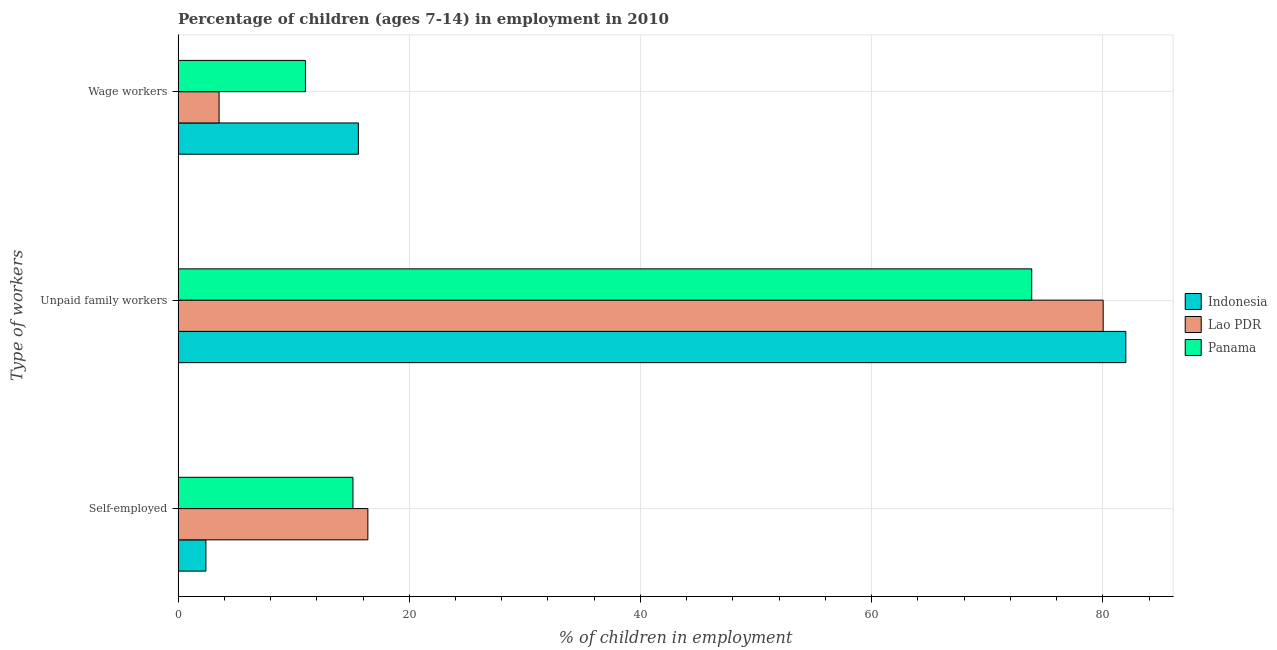What is the label of the 1st group of bars from the top?
Ensure brevity in your answer.  Wage workers. What is the percentage of children employed as wage workers in Panama?
Your answer should be very brief. 11.02. Across all countries, what is the maximum percentage of self employed children?
Offer a terse response. 16.42. Across all countries, what is the minimum percentage of children employed as wage workers?
Provide a short and direct response. 3.55. In which country was the percentage of children employed as wage workers maximum?
Keep it short and to the point. Indonesia. In which country was the percentage of self employed children minimum?
Give a very brief answer. Indonesia. What is the total percentage of self employed children in the graph?
Your answer should be very brief. 33.96. What is the difference between the percentage of children employed as wage workers in Indonesia and that in Lao PDR?
Your response must be concise. 12.05. What is the difference between the percentage of self employed children in Lao PDR and the percentage of children employed as unpaid family workers in Panama?
Keep it short and to the point. -57.43. What is the average percentage of children employed as wage workers per country?
Provide a short and direct response. 10.06. What is the difference between the percentage of self employed children and percentage of children employed as unpaid family workers in Indonesia?
Your response must be concise. -79.58. In how many countries, is the percentage of self employed children greater than 80 %?
Ensure brevity in your answer.  0. What is the ratio of the percentage of self employed children in Lao PDR to that in Panama?
Keep it short and to the point. 1.09. Is the percentage of children employed as wage workers in Panama less than that in Lao PDR?
Keep it short and to the point. No. What is the difference between the highest and the second highest percentage of children employed as unpaid family workers?
Keep it short and to the point. 1.96. What is the difference between the highest and the lowest percentage of children employed as unpaid family workers?
Your answer should be compact. 8.14. In how many countries, is the percentage of self employed children greater than the average percentage of self employed children taken over all countries?
Offer a terse response. 2. What does the 2nd bar from the bottom in Self-employed represents?
Your answer should be very brief. Lao PDR. Is it the case that in every country, the sum of the percentage of self employed children and percentage of children employed as unpaid family workers is greater than the percentage of children employed as wage workers?
Your answer should be very brief. Yes. How many bars are there?
Your answer should be compact. 9. Does the graph contain any zero values?
Provide a succinct answer. No. Does the graph contain grids?
Provide a short and direct response. Yes. Where does the legend appear in the graph?
Offer a very short reply. Center right. What is the title of the graph?
Offer a terse response. Percentage of children (ages 7-14) in employment in 2010. Does "St. Lucia" appear as one of the legend labels in the graph?
Offer a very short reply. No. What is the label or title of the X-axis?
Ensure brevity in your answer.  % of children in employment. What is the label or title of the Y-axis?
Offer a very short reply. Type of workers. What is the % of children in employment of Indonesia in Self-employed?
Your answer should be very brief. 2.41. What is the % of children in employment in Lao PDR in Self-employed?
Give a very brief answer. 16.42. What is the % of children in employment in Panama in Self-employed?
Provide a short and direct response. 15.13. What is the % of children in employment of Indonesia in Unpaid family workers?
Your answer should be compact. 81.99. What is the % of children in employment in Lao PDR in Unpaid family workers?
Give a very brief answer. 80.03. What is the % of children in employment of Panama in Unpaid family workers?
Give a very brief answer. 73.85. What is the % of children in employment in Indonesia in Wage workers?
Provide a short and direct response. 15.6. What is the % of children in employment of Lao PDR in Wage workers?
Offer a very short reply. 3.55. What is the % of children in employment in Panama in Wage workers?
Offer a terse response. 11.02. Across all Type of workers, what is the maximum % of children in employment in Indonesia?
Provide a short and direct response. 81.99. Across all Type of workers, what is the maximum % of children in employment in Lao PDR?
Make the answer very short. 80.03. Across all Type of workers, what is the maximum % of children in employment of Panama?
Keep it short and to the point. 73.85. Across all Type of workers, what is the minimum % of children in employment of Indonesia?
Your answer should be very brief. 2.41. Across all Type of workers, what is the minimum % of children in employment in Lao PDR?
Offer a very short reply. 3.55. Across all Type of workers, what is the minimum % of children in employment in Panama?
Ensure brevity in your answer.  11.02. What is the total % of children in employment in Indonesia in the graph?
Your answer should be compact. 100. What is the difference between the % of children in employment in Indonesia in Self-employed and that in Unpaid family workers?
Ensure brevity in your answer.  -79.58. What is the difference between the % of children in employment of Lao PDR in Self-employed and that in Unpaid family workers?
Keep it short and to the point. -63.61. What is the difference between the % of children in employment of Panama in Self-employed and that in Unpaid family workers?
Your response must be concise. -58.72. What is the difference between the % of children in employment of Indonesia in Self-employed and that in Wage workers?
Your answer should be very brief. -13.19. What is the difference between the % of children in employment in Lao PDR in Self-employed and that in Wage workers?
Give a very brief answer. 12.87. What is the difference between the % of children in employment in Panama in Self-employed and that in Wage workers?
Make the answer very short. 4.11. What is the difference between the % of children in employment of Indonesia in Unpaid family workers and that in Wage workers?
Provide a short and direct response. 66.39. What is the difference between the % of children in employment of Lao PDR in Unpaid family workers and that in Wage workers?
Provide a short and direct response. 76.48. What is the difference between the % of children in employment in Panama in Unpaid family workers and that in Wage workers?
Keep it short and to the point. 62.83. What is the difference between the % of children in employment of Indonesia in Self-employed and the % of children in employment of Lao PDR in Unpaid family workers?
Provide a succinct answer. -77.62. What is the difference between the % of children in employment in Indonesia in Self-employed and the % of children in employment in Panama in Unpaid family workers?
Offer a terse response. -71.44. What is the difference between the % of children in employment in Lao PDR in Self-employed and the % of children in employment in Panama in Unpaid family workers?
Offer a terse response. -57.43. What is the difference between the % of children in employment of Indonesia in Self-employed and the % of children in employment of Lao PDR in Wage workers?
Offer a very short reply. -1.14. What is the difference between the % of children in employment of Indonesia in Self-employed and the % of children in employment of Panama in Wage workers?
Make the answer very short. -8.61. What is the difference between the % of children in employment in Lao PDR in Self-employed and the % of children in employment in Panama in Wage workers?
Ensure brevity in your answer.  5.4. What is the difference between the % of children in employment in Indonesia in Unpaid family workers and the % of children in employment in Lao PDR in Wage workers?
Keep it short and to the point. 78.44. What is the difference between the % of children in employment of Indonesia in Unpaid family workers and the % of children in employment of Panama in Wage workers?
Your answer should be compact. 70.97. What is the difference between the % of children in employment of Lao PDR in Unpaid family workers and the % of children in employment of Panama in Wage workers?
Ensure brevity in your answer.  69.01. What is the average % of children in employment in Indonesia per Type of workers?
Keep it short and to the point. 33.33. What is the average % of children in employment of Lao PDR per Type of workers?
Ensure brevity in your answer.  33.33. What is the average % of children in employment of Panama per Type of workers?
Your response must be concise. 33.33. What is the difference between the % of children in employment in Indonesia and % of children in employment in Lao PDR in Self-employed?
Ensure brevity in your answer.  -14.01. What is the difference between the % of children in employment of Indonesia and % of children in employment of Panama in Self-employed?
Your response must be concise. -12.72. What is the difference between the % of children in employment in Lao PDR and % of children in employment in Panama in Self-employed?
Provide a short and direct response. 1.29. What is the difference between the % of children in employment in Indonesia and % of children in employment in Lao PDR in Unpaid family workers?
Your answer should be very brief. 1.96. What is the difference between the % of children in employment in Indonesia and % of children in employment in Panama in Unpaid family workers?
Provide a succinct answer. 8.14. What is the difference between the % of children in employment in Lao PDR and % of children in employment in Panama in Unpaid family workers?
Offer a terse response. 6.18. What is the difference between the % of children in employment of Indonesia and % of children in employment of Lao PDR in Wage workers?
Offer a terse response. 12.05. What is the difference between the % of children in employment in Indonesia and % of children in employment in Panama in Wage workers?
Your answer should be compact. 4.58. What is the difference between the % of children in employment of Lao PDR and % of children in employment of Panama in Wage workers?
Offer a very short reply. -7.47. What is the ratio of the % of children in employment in Indonesia in Self-employed to that in Unpaid family workers?
Ensure brevity in your answer.  0.03. What is the ratio of the % of children in employment in Lao PDR in Self-employed to that in Unpaid family workers?
Give a very brief answer. 0.21. What is the ratio of the % of children in employment in Panama in Self-employed to that in Unpaid family workers?
Make the answer very short. 0.2. What is the ratio of the % of children in employment in Indonesia in Self-employed to that in Wage workers?
Offer a very short reply. 0.15. What is the ratio of the % of children in employment of Lao PDR in Self-employed to that in Wage workers?
Offer a very short reply. 4.63. What is the ratio of the % of children in employment of Panama in Self-employed to that in Wage workers?
Offer a terse response. 1.37. What is the ratio of the % of children in employment in Indonesia in Unpaid family workers to that in Wage workers?
Ensure brevity in your answer.  5.26. What is the ratio of the % of children in employment of Lao PDR in Unpaid family workers to that in Wage workers?
Your answer should be compact. 22.54. What is the ratio of the % of children in employment of Panama in Unpaid family workers to that in Wage workers?
Your answer should be compact. 6.7. What is the difference between the highest and the second highest % of children in employment of Indonesia?
Offer a very short reply. 66.39. What is the difference between the highest and the second highest % of children in employment in Lao PDR?
Ensure brevity in your answer.  63.61. What is the difference between the highest and the second highest % of children in employment of Panama?
Offer a very short reply. 58.72. What is the difference between the highest and the lowest % of children in employment of Indonesia?
Keep it short and to the point. 79.58. What is the difference between the highest and the lowest % of children in employment of Lao PDR?
Ensure brevity in your answer.  76.48. What is the difference between the highest and the lowest % of children in employment of Panama?
Offer a very short reply. 62.83. 